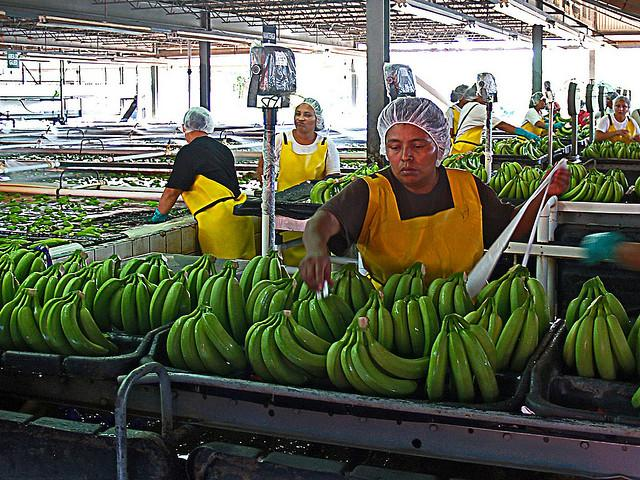What does the hair cap prevent? hair falling 